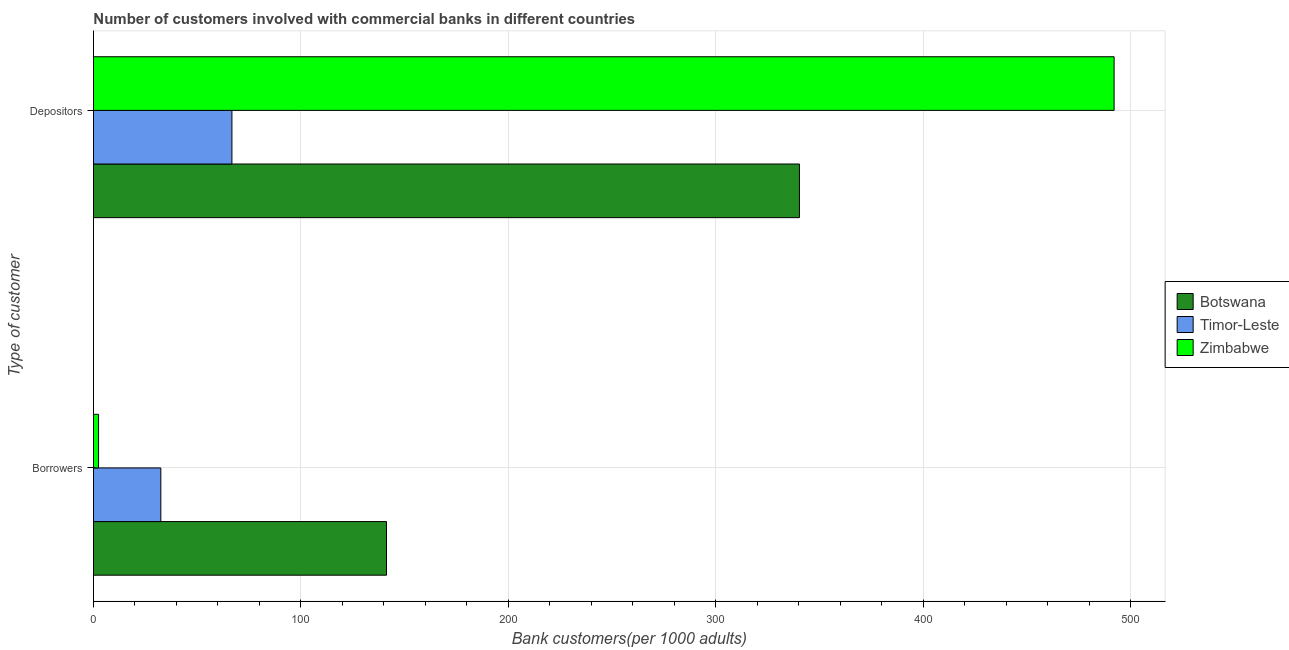How many groups of bars are there?
Provide a short and direct response. 2. How many bars are there on the 1st tick from the top?
Provide a succinct answer. 3. How many bars are there on the 2nd tick from the bottom?
Offer a terse response. 3. What is the label of the 1st group of bars from the top?
Your answer should be compact. Depositors. What is the number of borrowers in Botswana?
Your answer should be compact. 141.29. Across all countries, what is the maximum number of borrowers?
Give a very brief answer. 141.29. Across all countries, what is the minimum number of depositors?
Give a very brief answer. 66.76. In which country was the number of borrowers maximum?
Keep it short and to the point. Botswana. In which country was the number of depositors minimum?
Your response must be concise. Timor-Leste. What is the total number of depositors in the graph?
Offer a terse response. 899.21. What is the difference between the number of borrowers in Timor-Leste and that in Botswana?
Provide a short and direct response. -108.8. What is the difference between the number of borrowers in Timor-Leste and the number of depositors in Zimbabwe?
Make the answer very short. -459.6. What is the average number of borrowers per country?
Provide a short and direct response. 58.74. What is the difference between the number of depositors and number of borrowers in Timor-Leste?
Your response must be concise. 34.28. What is the ratio of the number of borrowers in Timor-Leste to that in Zimbabwe?
Your answer should be compact. 13.2. Is the number of borrowers in Timor-Leste less than that in Zimbabwe?
Provide a short and direct response. No. What does the 3rd bar from the top in Borrowers represents?
Give a very brief answer. Botswana. What does the 2nd bar from the bottom in Depositors represents?
Make the answer very short. Timor-Leste. How many countries are there in the graph?
Offer a terse response. 3. Are the values on the major ticks of X-axis written in scientific E-notation?
Your answer should be very brief. No. Does the graph contain any zero values?
Your response must be concise. No. Does the graph contain grids?
Provide a succinct answer. Yes. Where does the legend appear in the graph?
Make the answer very short. Center right. What is the title of the graph?
Keep it short and to the point. Number of customers involved with commercial banks in different countries. What is the label or title of the X-axis?
Ensure brevity in your answer.  Bank customers(per 1000 adults). What is the label or title of the Y-axis?
Provide a succinct answer. Type of customer. What is the Bank customers(per 1000 adults) of Botswana in Borrowers?
Provide a short and direct response. 141.29. What is the Bank customers(per 1000 adults) of Timor-Leste in Borrowers?
Make the answer very short. 32.48. What is the Bank customers(per 1000 adults) in Zimbabwe in Borrowers?
Ensure brevity in your answer.  2.46. What is the Bank customers(per 1000 adults) in Botswana in Depositors?
Your response must be concise. 340.37. What is the Bank customers(per 1000 adults) in Timor-Leste in Depositors?
Give a very brief answer. 66.76. What is the Bank customers(per 1000 adults) of Zimbabwe in Depositors?
Make the answer very short. 492.08. Across all Type of customer, what is the maximum Bank customers(per 1000 adults) in Botswana?
Offer a terse response. 340.37. Across all Type of customer, what is the maximum Bank customers(per 1000 adults) in Timor-Leste?
Offer a terse response. 66.76. Across all Type of customer, what is the maximum Bank customers(per 1000 adults) of Zimbabwe?
Provide a succinct answer. 492.08. Across all Type of customer, what is the minimum Bank customers(per 1000 adults) in Botswana?
Make the answer very short. 141.29. Across all Type of customer, what is the minimum Bank customers(per 1000 adults) in Timor-Leste?
Make the answer very short. 32.48. Across all Type of customer, what is the minimum Bank customers(per 1000 adults) of Zimbabwe?
Offer a terse response. 2.46. What is the total Bank customers(per 1000 adults) of Botswana in the graph?
Provide a succinct answer. 481.66. What is the total Bank customers(per 1000 adults) of Timor-Leste in the graph?
Offer a very short reply. 99.25. What is the total Bank customers(per 1000 adults) of Zimbabwe in the graph?
Keep it short and to the point. 494.54. What is the difference between the Bank customers(per 1000 adults) of Botswana in Borrowers and that in Depositors?
Keep it short and to the point. -199.09. What is the difference between the Bank customers(per 1000 adults) in Timor-Leste in Borrowers and that in Depositors?
Offer a terse response. -34.28. What is the difference between the Bank customers(per 1000 adults) in Zimbabwe in Borrowers and that in Depositors?
Ensure brevity in your answer.  -489.62. What is the difference between the Bank customers(per 1000 adults) of Botswana in Borrowers and the Bank customers(per 1000 adults) of Timor-Leste in Depositors?
Keep it short and to the point. 74.52. What is the difference between the Bank customers(per 1000 adults) of Botswana in Borrowers and the Bank customers(per 1000 adults) of Zimbabwe in Depositors?
Keep it short and to the point. -350.79. What is the difference between the Bank customers(per 1000 adults) of Timor-Leste in Borrowers and the Bank customers(per 1000 adults) of Zimbabwe in Depositors?
Provide a succinct answer. -459.6. What is the average Bank customers(per 1000 adults) in Botswana per Type of customer?
Ensure brevity in your answer.  240.83. What is the average Bank customers(per 1000 adults) in Timor-Leste per Type of customer?
Your response must be concise. 49.62. What is the average Bank customers(per 1000 adults) in Zimbabwe per Type of customer?
Offer a terse response. 247.27. What is the difference between the Bank customers(per 1000 adults) in Botswana and Bank customers(per 1000 adults) in Timor-Leste in Borrowers?
Provide a short and direct response. 108.8. What is the difference between the Bank customers(per 1000 adults) of Botswana and Bank customers(per 1000 adults) of Zimbabwe in Borrowers?
Offer a very short reply. 138.83. What is the difference between the Bank customers(per 1000 adults) of Timor-Leste and Bank customers(per 1000 adults) of Zimbabwe in Borrowers?
Offer a terse response. 30.02. What is the difference between the Bank customers(per 1000 adults) in Botswana and Bank customers(per 1000 adults) in Timor-Leste in Depositors?
Your answer should be very brief. 273.61. What is the difference between the Bank customers(per 1000 adults) of Botswana and Bank customers(per 1000 adults) of Zimbabwe in Depositors?
Provide a succinct answer. -151.71. What is the difference between the Bank customers(per 1000 adults) of Timor-Leste and Bank customers(per 1000 adults) of Zimbabwe in Depositors?
Give a very brief answer. -425.32. What is the ratio of the Bank customers(per 1000 adults) of Botswana in Borrowers to that in Depositors?
Give a very brief answer. 0.42. What is the ratio of the Bank customers(per 1000 adults) of Timor-Leste in Borrowers to that in Depositors?
Keep it short and to the point. 0.49. What is the ratio of the Bank customers(per 1000 adults) in Zimbabwe in Borrowers to that in Depositors?
Your answer should be compact. 0.01. What is the difference between the highest and the second highest Bank customers(per 1000 adults) of Botswana?
Give a very brief answer. 199.09. What is the difference between the highest and the second highest Bank customers(per 1000 adults) of Timor-Leste?
Offer a terse response. 34.28. What is the difference between the highest and the second highest Bank customers(per 1000 adults) of Zimbabwe?
Offer a terse response. 489.62. What is the difference between the highest and the lowest Bank customers(per 1000 adults) in Botswana?
Your response must be concise. 199.09. What is the difference between the highest and the lowest Bank customers(per 1000 adults) in Timor-Leste?
Keep it short and to the point. 34.28. What is the difference between the highest and the lowest Bank customers(per 1000 adults) of Zimbabwe?
Provide a short and direct response. 489.62. 